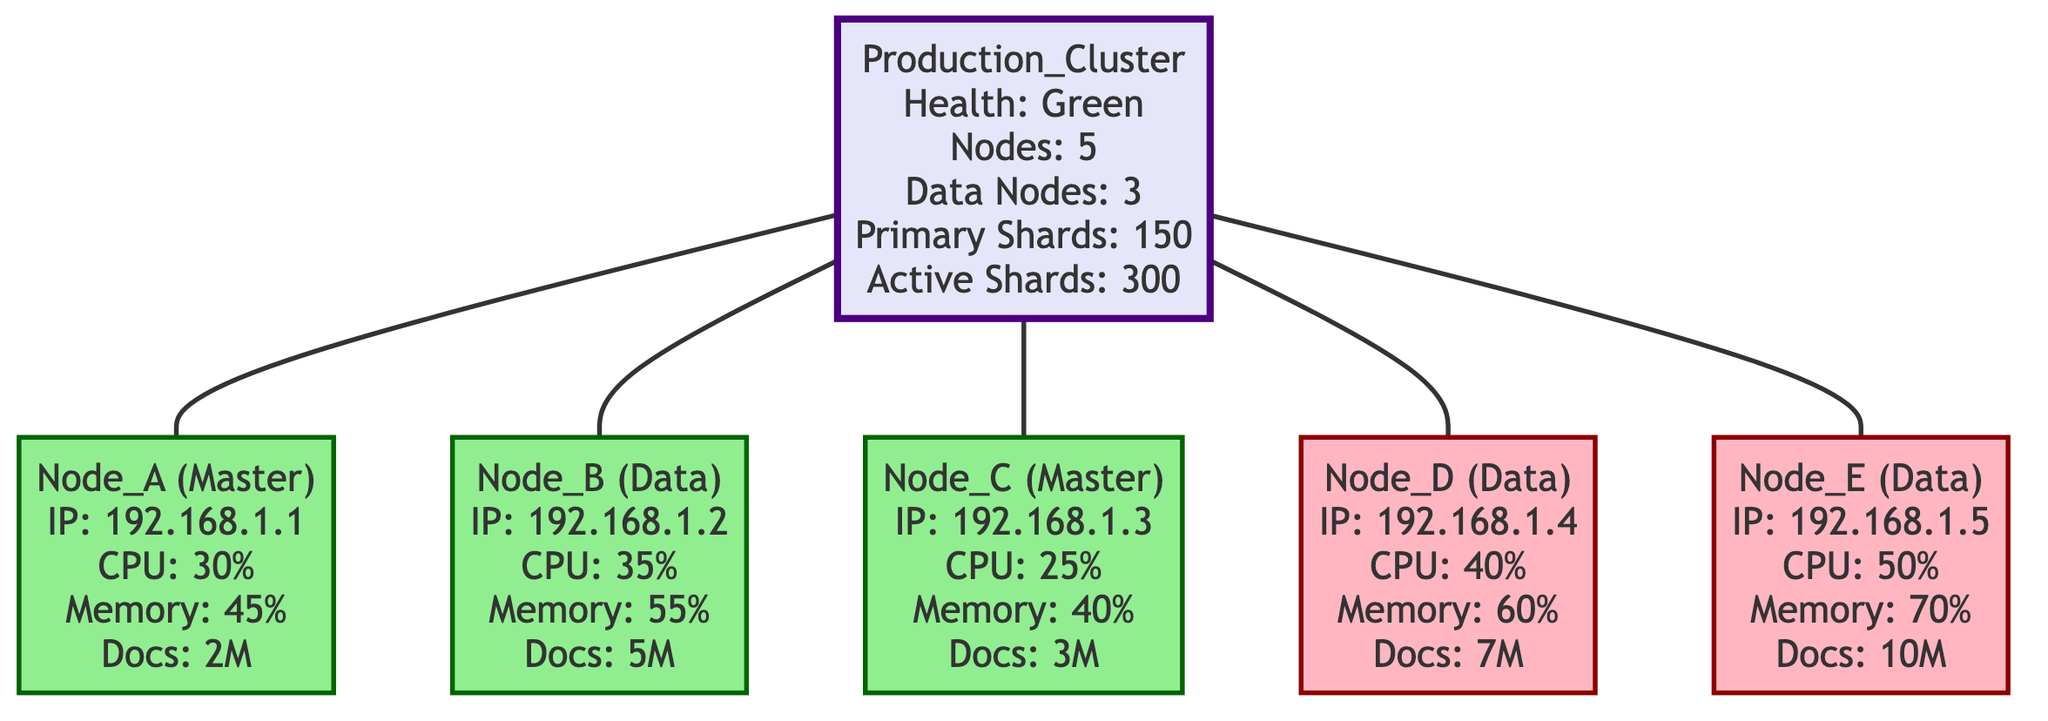What is the health status of the cluster? The health status of the cluster is specified in the diagram under the "Production_Cluster" label, where it states "Health: Green".
Answer: green How many nodes are there in the cluster? The total number of nodes is mentioned within the cluster information. It states "Nodes: 5". Therefore, there are a total of 5 nodes.
Answer: 5 Which nodes are marked as needing attention? By examining the nodes in the diagram, Node_D and Node_E are classified as "needs attention" in their respective statuses.
Answer: Node_D, Node_E What is the IP address of Node_B? The IP address of Node_B is displayed directly in its section of the diagram. It states "IP: 192.168.1.2".
Answer: 192.168.1.2 How many active primary shards are in the cluster? The number of active primary shards is explicitly stated in the cluster information: "Primary Shards: 150".  Therefore, there are 150 active primary shards.
Answer: 150 Which node has the highest CPU usage percentage? To determine which node has the highest CPU usage, we compare the CPU usage percentages listed for each node. Node_E has the highest at 50%.
Answer: Node_E What is the total number of documents indexed across all nodes? The total documents indexed can be calculated by adding the figures for each node: 2M (Node_A) + 5M (Node_B) + 3M (Node_C) + 7M (Node_D) + 10M (Node_E) = 27M documents total.
Answer: 27M How many data nodes are present in the cluster? The breakdown of node roles in the cluster states "Data Nodes: 3". Thus, there are 3 nodes that serve as data nodes.
Answer: 3 What is the disk availability of Node_C? The available disk space for Node_C is stated in its section as "Disk Available: 150GB".
Answer: 150GB 